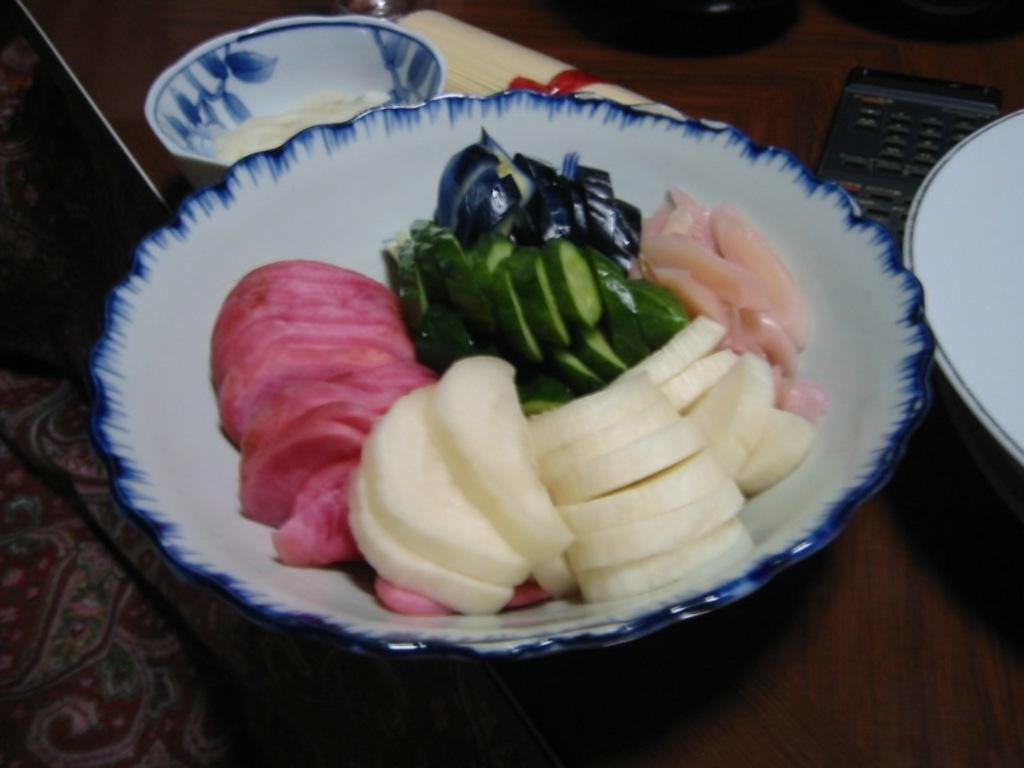What is in the bowl that is visible in the image? There is a bowl with food in the image. What type of food can be seen in the bowl? The food includes meat and cucumber. Are there any other containers with food material in the image? Yes, there is another bowl with food material in the image. What other dish can be seen in the image? There is a plate in the image. What type of clouds can be seen in the image? There are no clouds present in the image; it features a bowl with food, another bowl, and a plate. 